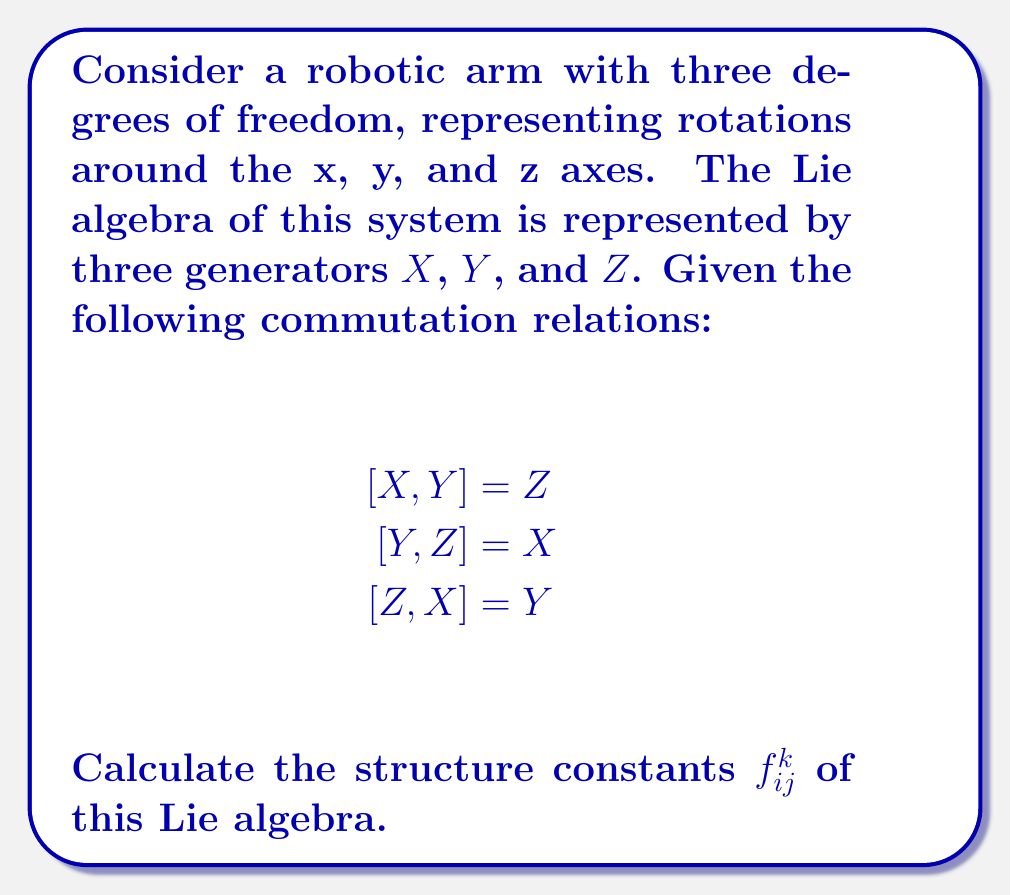What is the answer to this math problem? To calculate the structure constants of this Lie algebra, we need to follow these steps:

1) The structure constants $f_{ij}^k$ are defined by the commutation relations:

   $$[X_i, X_j] = \sum_k f_{ij}^k X_k$$

   where $X_i$, $X_j$, and $X_k$ are basis elements of the Lie algebra.

2) In our case, we have three basis elements: $X_1 = X$, $X_2 = Y$, and $X_3 = Z$.

3) Let's analyze each commutation relation:

   a) $[X, Y] = Z$ implies $f_{12}^3 = 1$ and $f_{21}^3 = -1$
   b) $[Y, Z] = X$ implies $f_{23}^1 = 1$ and $f_{32}^1 = -1$
   c) $[Z, X] = Y$ implies $f_{31}^2 = 1$ and $f_{13}^2 = -1$

4) All other structure constants are zero.

5) We can represent these structure constants in a 3x3x3 array where $f_{ij}^k$ is the element in the $k$-th plane, $i$-th row, and $j$-th column.

6) The array would look like this:

   For $k = 1$ (X):
   $$\begin{pmatrix}
   0 & 0 & 0 \\
   0 & 0 & 1 \\
   0 & -1 & 0
   \end{pmatrix}$$

   For $k = 2$ (Y):
   $$\begin{pmatrix}
   0 & 0 & -1 \\
   0 & 0 & 0 \\
   1 & 0 & 0
   \end{pmatrix}$$

   For $k = 3$ (Z):
   $$\begin{pmatrix}
   0 & 1 & 0 \\
   -1 & 0 & 0 \\
   0 & 0 & 0
   \end{pmatrix}$$

This array fully describes the structure constants of the Lie algebra representing the robotic system's degrees of freedom.
Answer: The non-zero structure constants are:

$f_{12}^3 = 1$, $f_{21}^3 = -1$
$f_{23}^1 = 1$, $f_{32}^1 = -1$
$f_{31}^2 = 1$, $f_{13}^2 = -1$

All other structure constants are zero. 